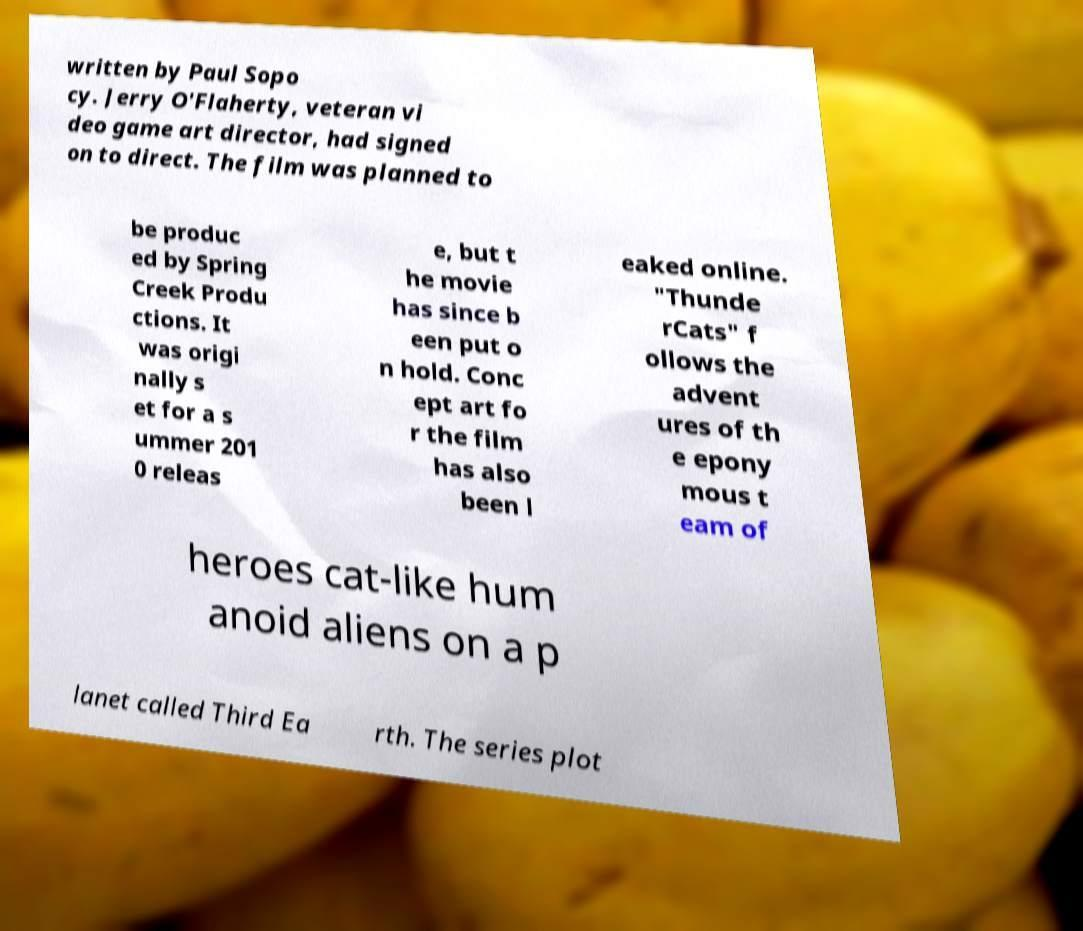Can you read and provide the text displayed in the image?This photo seems to have some interesting text. Can you extract and type it out for me? written by Paul Sopo cy. Jerry O'Flaherty, veteran vi deo game art director, had signed on to direct. The film was planned to be produc ed by Spring Creek Produ ctions. It was origi nally s et for a s ummer 201 0 releas e, but t he movie has since b een put o n hold. Conc ept art fo r the film has also been l eaked online. "Thunde rCats" f ollows the advent ures of th e epony mous t eam of heroes cat-like hum anoid aliens on a p lanet called Third Ea rth. The series plot 